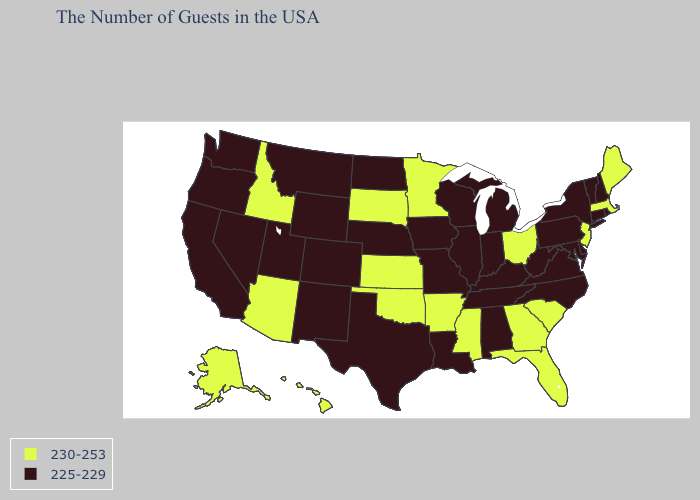What is the value of Oregon?
Keep it brief. 225-229. Does Virginia have the highest value in the South?
Keep it brief. No. Does the first symbol in the legend represent the smallest category?
Write a very short answer. No. Is the legend a continuous bar?
Concise answer only. No. Which states hav the highest value in the MidWest?
Write a very short answer. Ohio, Minnesota, Kansas, South Dakota. What is the value of Wisconsin?
Answer briefly. 225-229. Name the states that have a value in the range 230-253?
Be succinct. Maine, Massachusetts, New Jersey, South Carolina, Ohio, Florida, Georgia, Mississippi, Arkansas, Minnesota, Kansas, Oklahoma, South Dakota, Arizona, Idaho, Alaska, Hawaii. What is the value of Oklahoma?
Write a very short answer. 230-253. Name the states that have a value in the range 225-229?
Answer briefly. Rhode Island, New Hampshire, Vermont, Connecticut, New York, Delaware, Maryland, Pennsylvania, Virginia, North Carolina, West Virginia, Michigan, Kentucky, Indiana, Alabama, Tennessee, Wisconsin, Illinois, Louisiana, Missouri, Iowa, Nebraska, Texas, North Dakota, Wyoming, Colorado, New Mexico, Utah, Montana, Nevada, California, Washington, Oregon. Does the map have missing data?
Write a very short answer. No. What is the value of Oklahoma?
Keep it brief. 230-253. How many symbols are there in the legend?
Give a very brief answer. 2. Which states have the lowest value in the MidWest?
Concise answer only. Michigan, Indiana, Wisconsin, Illinois, Missouri, Iowa, Nebraska, North Dakota. Name the states that have a value in the range 225-229?
Quick response, please. Rhode Island, New Hampshire, Vermont, Connecticut, New York, Delaware, Maryland, Pennsylvania, Virginia, North Carolina, West Virginia, Michigan, Kentucky, Indiana, Alabama, Tennessee, Wisconsin, Illinois, Louisiana, Missouri, Iowa, Nebraska, Texas, North Dakota, Wyoming, Colorado, New Mexico, Utah, Montana, Nevada, California, Washington, Oregon. Does Mississippi have the highest value in the South?
Write a very short answer. Yes. 